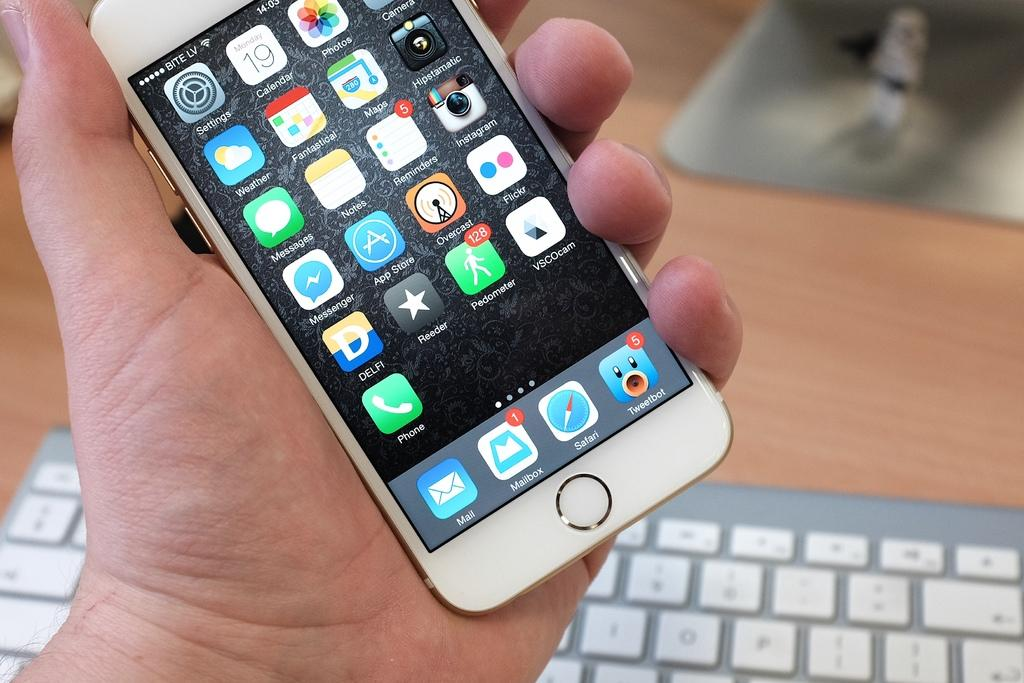What is placed on the wooden surface in the image? There is a keyboard on a wooden surface in the image. What is the person in the image doing with their hand? A person's hand is holding a phone in the image. How many stems can be seen growing from the keyboard in the image? There are no stems growing from the keyboard in the image. Is there a horse present in the image? No, there is no horse present in the image. 